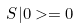<formula> <loc_0><loc_0><loc_500><loc_500>S | 0 > = 0</formula> 